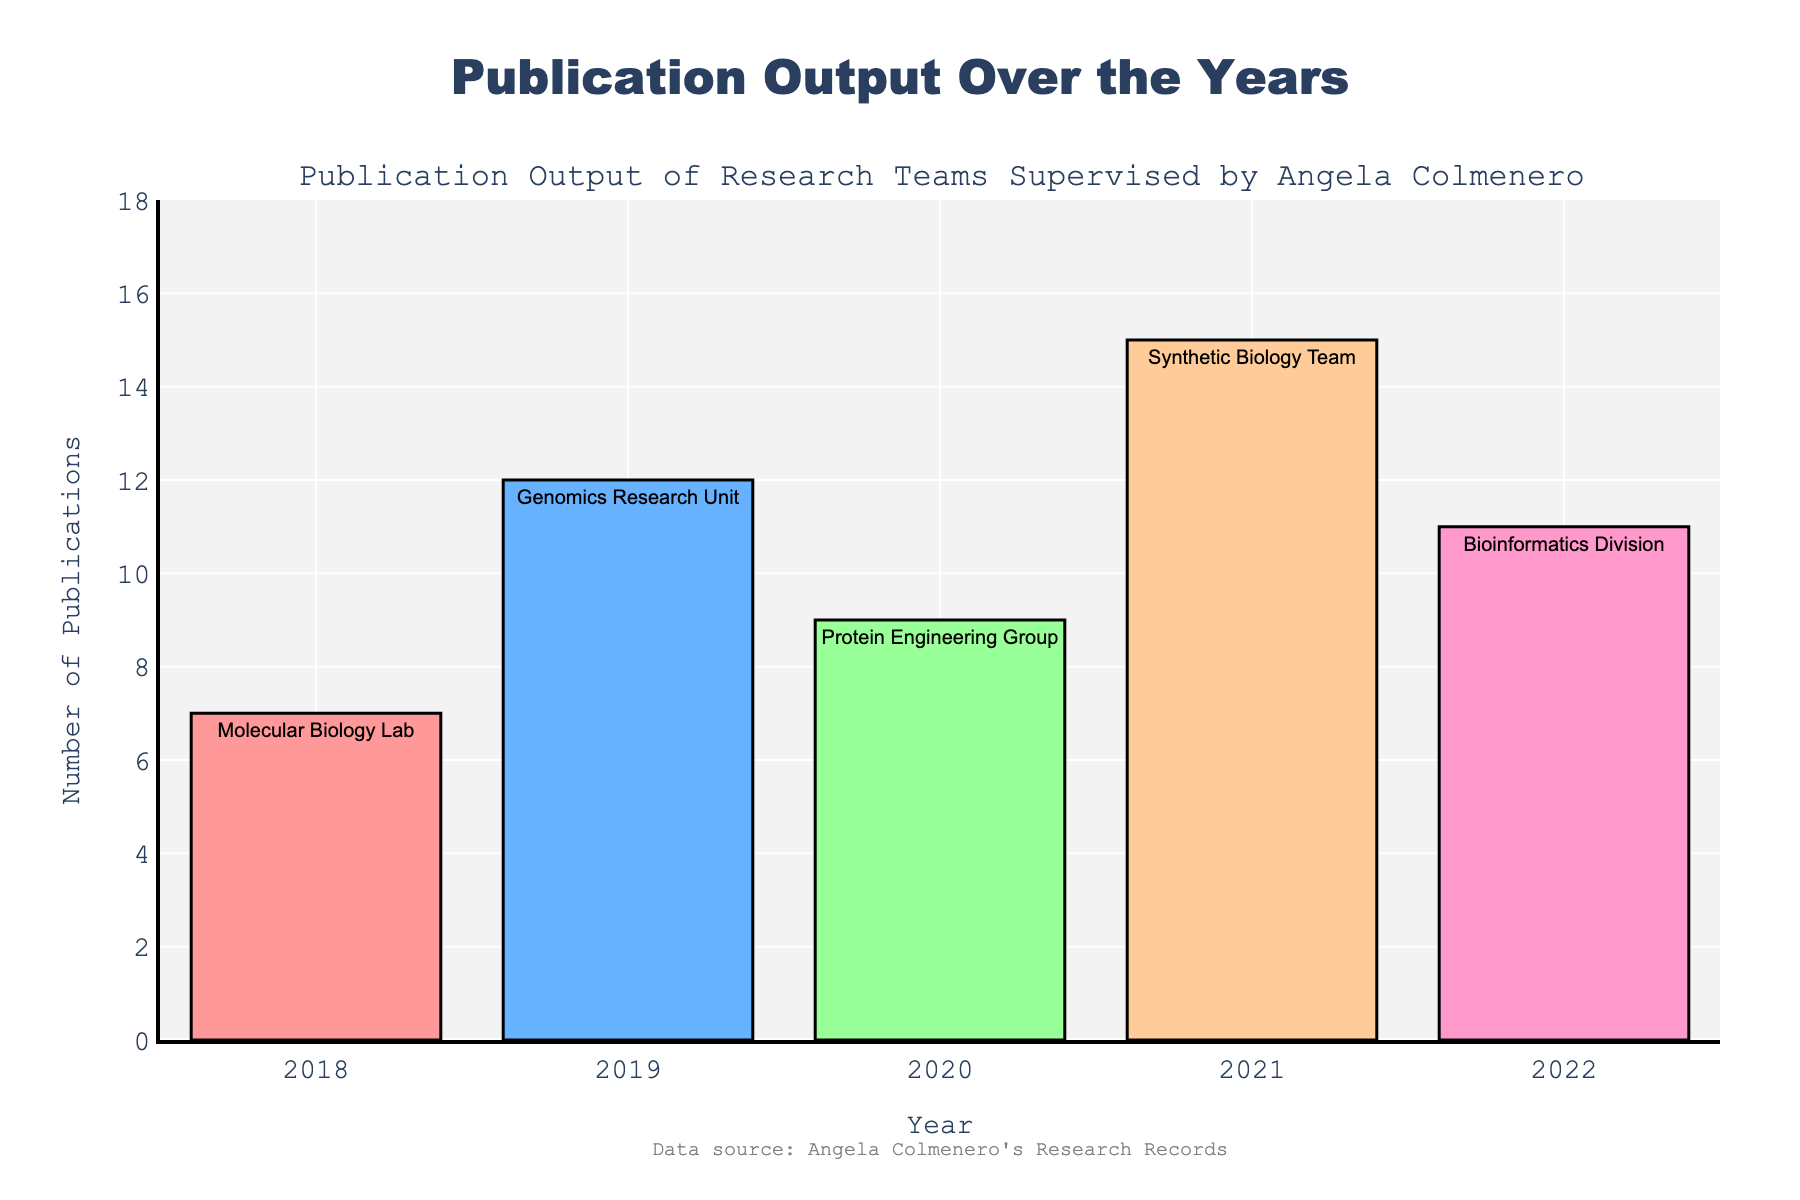What's the average number of publications per year? To calculate the average, add all the publications from 2018 to 2022: (7 + 12 + 9 + 15 + 11) = 54. Then divide by the number of years (5): 54 / 5 = 10.8
Answer: 10.8 Which year had the highest number of publications? Observe the bar heights and labels; the year 2021 has the highest bar with 15 publications.
Answer: 2021 How many more publications were there in 2021 compared to 2018? Look at the bars for 2018 and 2021. Subtract the number of publications in 2018 from 2021: 15 - 7 = 8
Answer: 8 What is the total number of publications in 2019 and 2020? Add the number of publications for 2019 and 2020: 12 + 9 = 21
Answer: 21 Which team had the fewest publications, and in which year was this? Notice the bar for each year and examine the labels. The fewest publications were 7 by the Molecular Biology Lab in 2018.
Answer: Molecular Biology Lab, 2018 By how much did the number of publications increase from 2018 to 2019? Subtract the number of publications in 2018 from 2019: 12 - 7 = 5
Answer: 5 What’s the difference in publication numbers between the Synthetic Biology Team in 2021 and the Bioinformatics Division in 2022? Subtract the publications of Bioinformatics Division in 2022 from the Synthetic Biology Team in 2021: 15 - 11 = 4
Answer: 4 Which color represents the Genomics Research Unit, and how many publications did they have? Identify the bar color for 2019, which is blue, relating to the Genomics Research Unit with 12 publications.
Answer: Blue, 12 What is the median number of publications over these years? Arrange the publications in ascending order: 7, 9, 11, 12, 15. The middle value (median) is 11.
Answer: 11 What is the difference in publications between the highest and lowest years? The highest publication count is 15 (2021) and the lowest is 7 (2018). Calculate the difference: 15 - 7 = 8
Answer: 8 